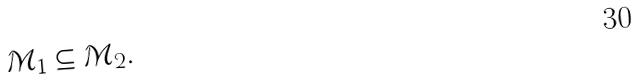Convert formula to latex. <formula><loc_0><loc_0><loc_500><loc_500>\mathcal { M } _ { 1 } \subseteq \mathcal { M } _ { 2 } .</formula> 